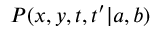<formula> <loc_0><loc_0><loc_500><loc_500>P ( x , y , t , t ^ { \prime } | { a } , { b } )</formula> 